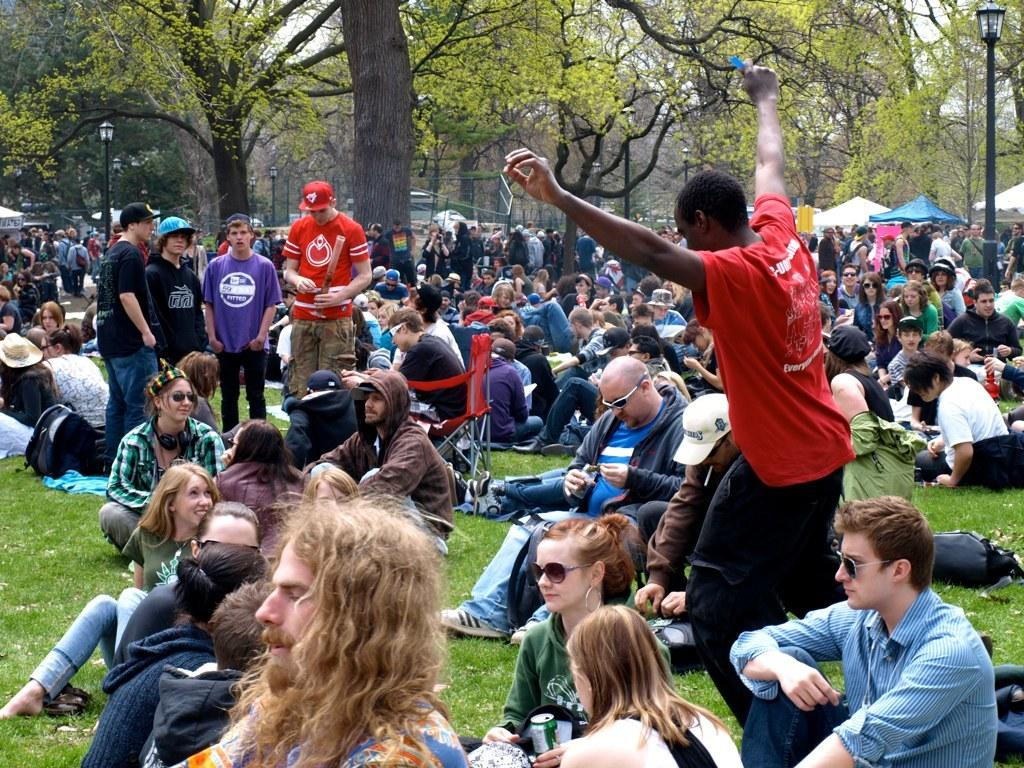What are the people in the image doing? The people in the image are sitting and standing on the ground. What objects are present to provide shade in the image? Parasols are present in the image. What type of natural elements can be seen in the image? Trees are visible in the image. What man-made structures are present in the image? Street poles and street lights are present in the image. What is visible in the sky in the image? The sky is visible in the image. What type of creature is responsible for the waste seen in the image? There is no waste visible in the image, so it is not possible to determine what type of creature might be responsible. 